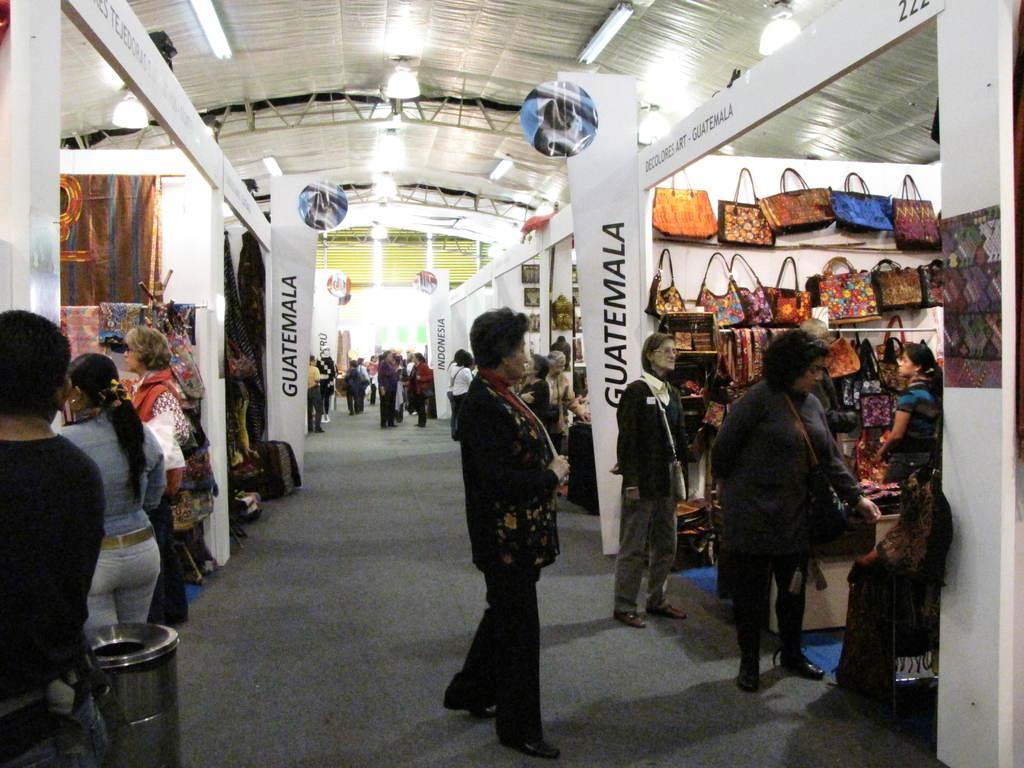In one or two sentences, can you explain what this image depicts? In this image in one building there are many stores. People are in front of the store. On the ceiling there are lights. This is a bag shop. In front of the shops there are hoardings. This is a dustbin. 